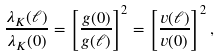Convert formula to latex. <formula><loc_0><loc_0><loc_500><loc_500>\frac { \lambda _ { K } ( \ell ) } { \lambda _ { K } ( 0 ) } = \left [ \frac { g ( 0 ) } { g ( \ell ) } \right ] ^ { 2 } = \left [ \frac { v ( \ell ) } { v ( 0 ) } \right ] ^ { 2 } ,</formula> 